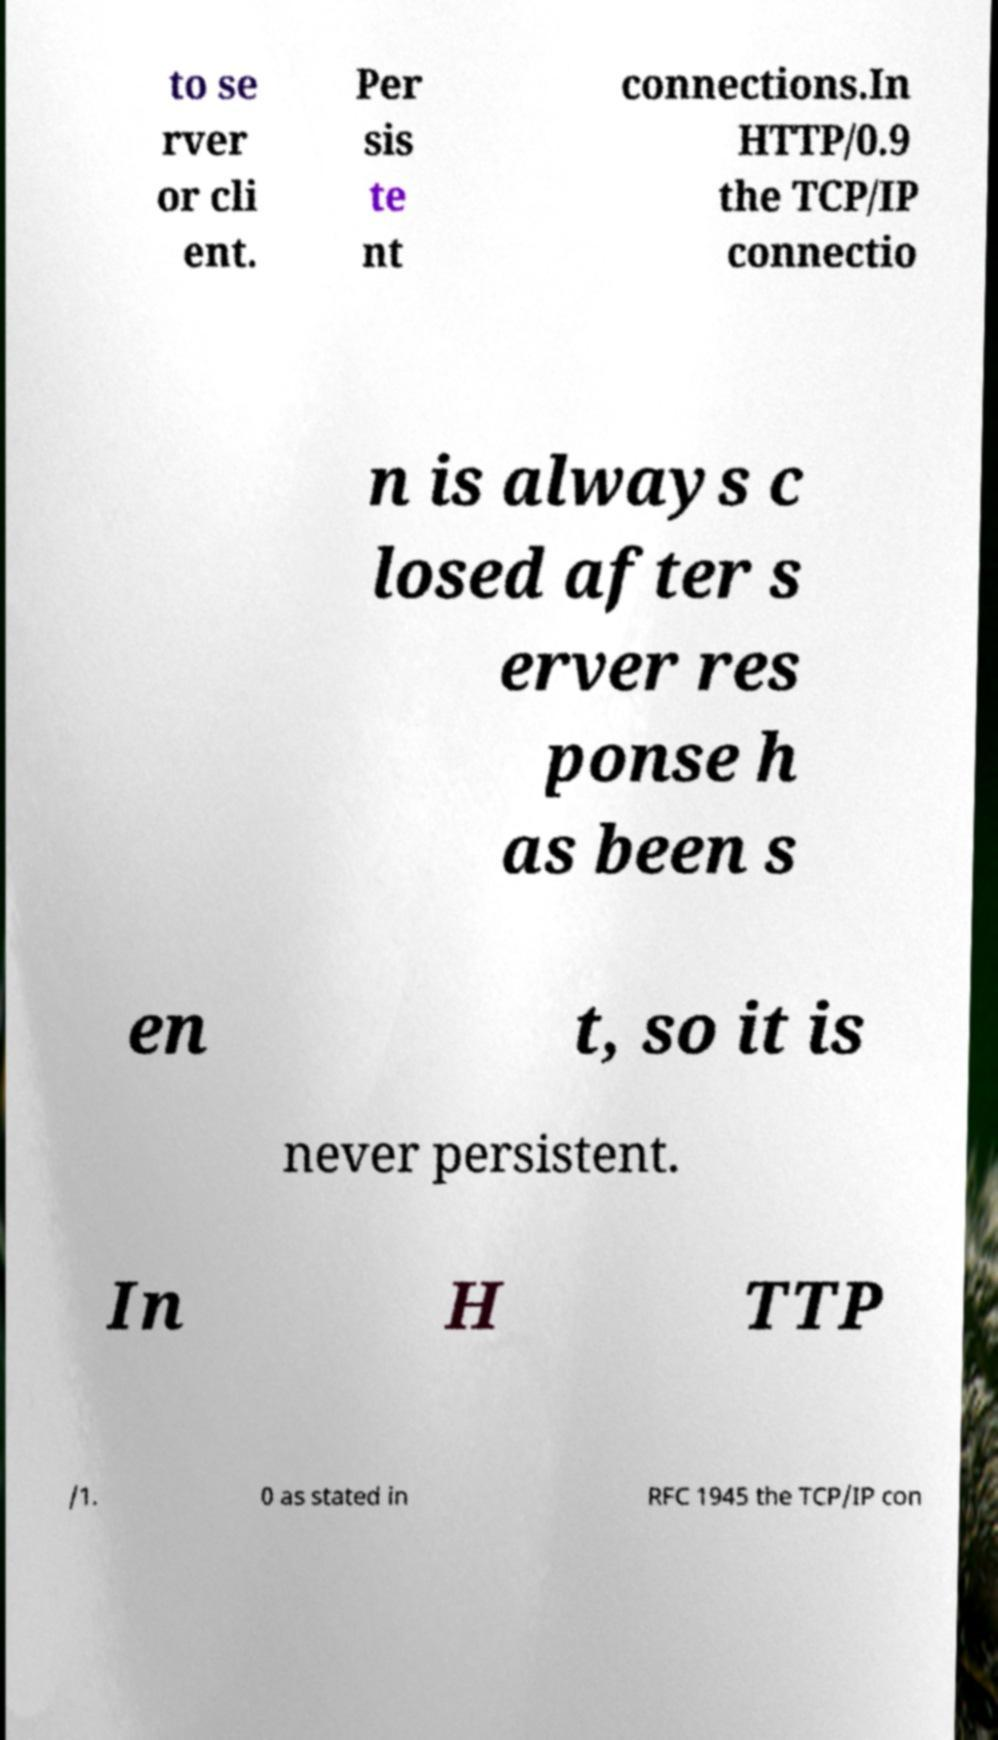I need the written content from this picture converted into text. Can you do that? to se rver or cli ent. Per sis te nt connections.In HTTP/0.9 the TCP/IP connectio n is always c losed after s erver res ponse h as been s en t, so it is never persistent. In H TTP /1. 0 as stated in RFC 1945 the TCP/IP con 